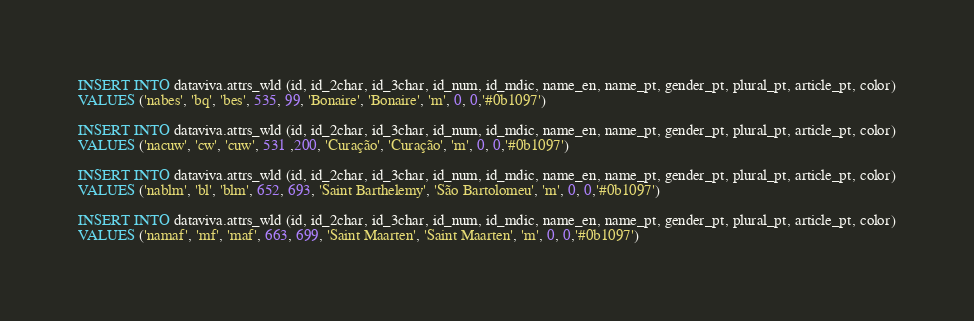<code> <loc_0><loc_0><loc_500><loc_500><_SQL_>INSERT INTO dataviva.attrs_wld (id, id_2char, id_3char, id_num, id_mdic, name_en, name_pt, gender_pt, plural_pt, article_pt, color)
VALUES ('nabes', 'bq', 'bes', 535, 99, 'Bonaire', 'Bonaire', 'm', 0, 0,'#0b1097')

INSERT INTO dataviva.attrs_wld (id, id_2char, id_3char, id_num, id_mdic, name_en, name_pt, gender_pt, plural_pt, article_pt, color)
VALUES ('nacuw', 'cw', 'cuw', 531 ,200, 'Curação', 'Curação', 'm', 0, 0,'#0b1097')

INSERT INTO dataviva.attrs_wld (id, id_2char, id_3char, id_num, id_mdic, name_en, name_pt, gender_pt, plural_pt, article_pt, color)
VALUES ('nablm', 'bl', 'blm', 652, 693, 'Saint Barthelemy', 'São Bartolomeu', 'm', 0, 0,'#0b1097')

INSERT INTO dataviva.attrs_wld (id, id_2char, id_3char, id_num, id_mdic, name_en, name_pt, gender_pt, plural_pt, article_pt, color)
VALUES ('namaf', 'mf', 'maf', 663, 699, 'Saint Maarten', 'Saint Maarten', 'm', 0, 0,'#0b1097')</code> 